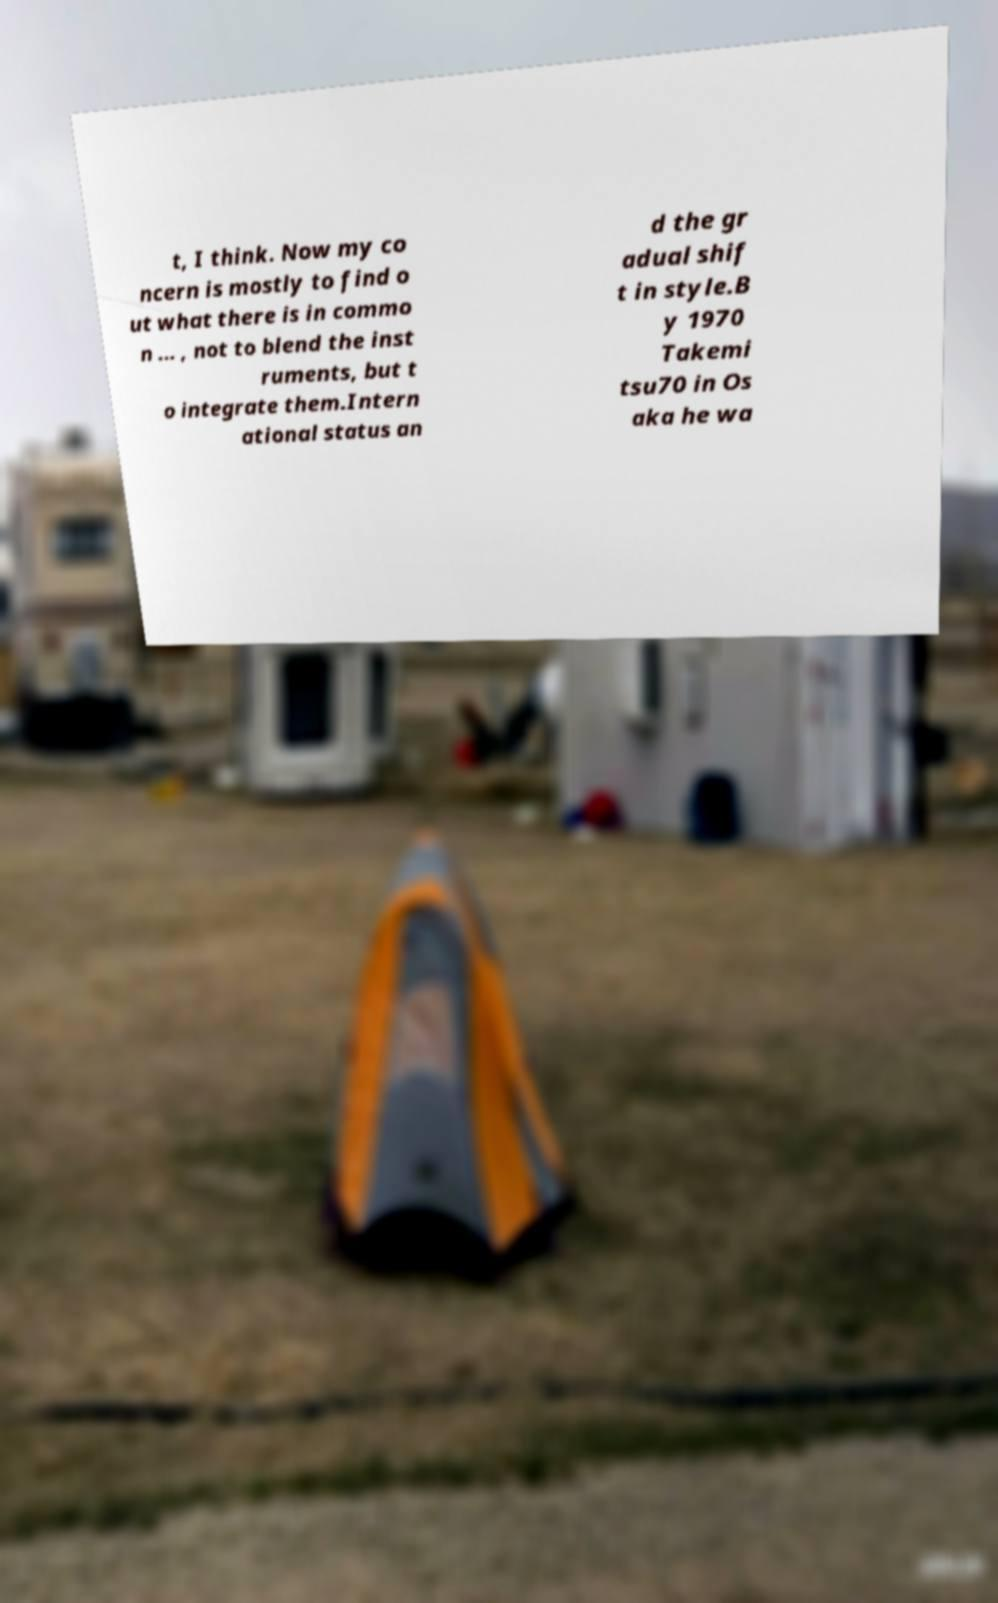Could you assist in decoding the text presented in this image and type it out clearly? t, I think. Now my co ncern is mostly to find o ut what there is in commo n ... , not to blend the inst ruments, but t o integrate them.Intern ational status an d the gr adual shif t in style.B y 1970 Takemi tsu70 in Os aka he wa 